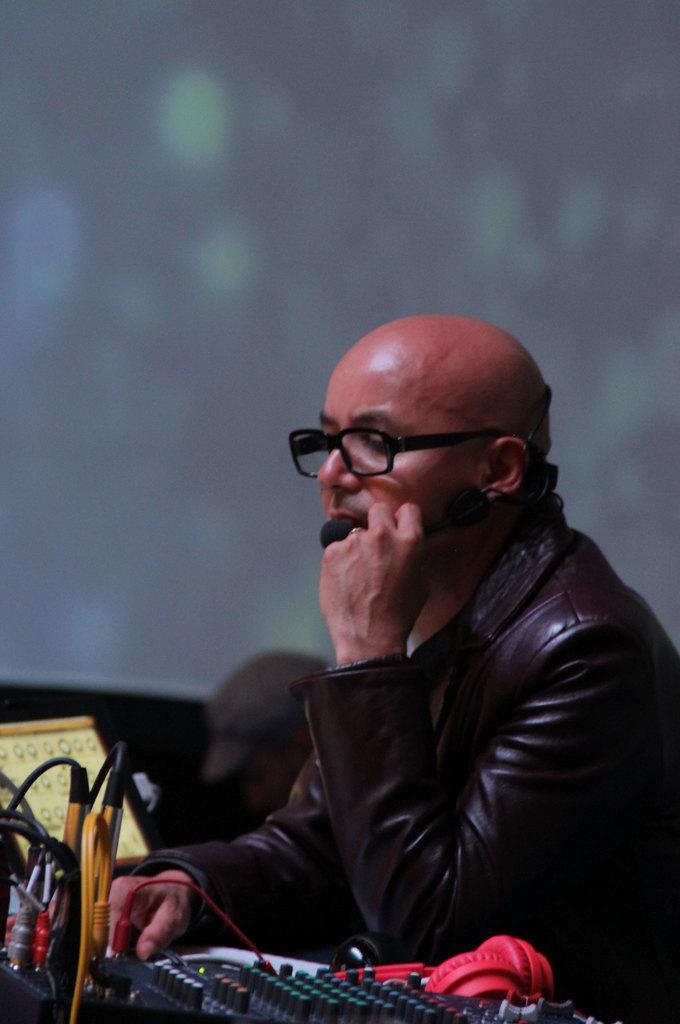Describe this image in one or two sentences. In this image I see a man who is wearing a jacket which is of brown in color and I see few equipment over here and I see the wires and I see that it is blurred in the background. 